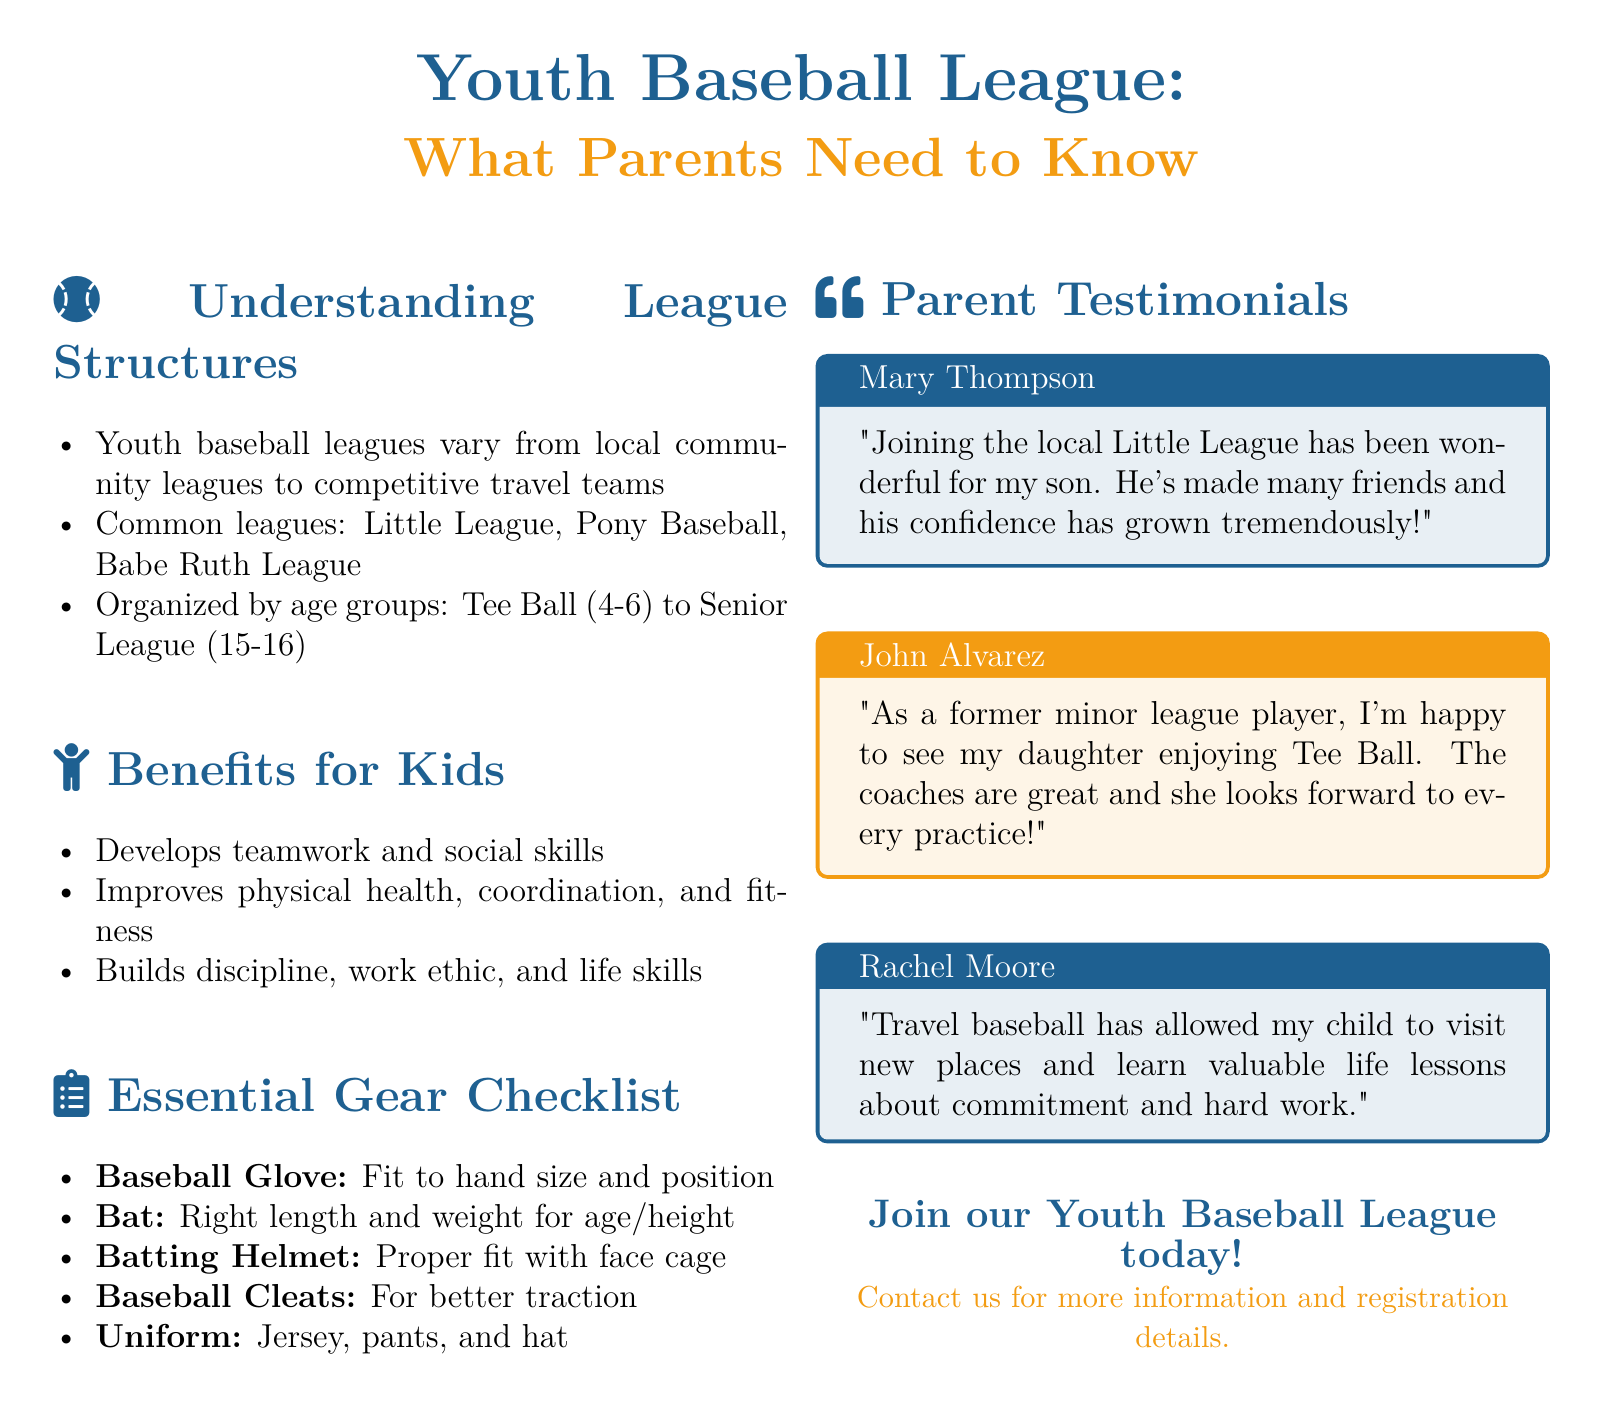What are the common leagues mentioned? The document lists common youth baseball leagues, which include Little League, Pony Baseball, and Babe Ruth League.
Answer: Little League, Pony Baseball, Babe Ruth League What is the age range for Tee Ball? Tee Ball is specifically organized for a certain age group, which is mentioned in the document.
Answer: 4-6 What essential gear is needed for youth baseball? The document provides a checklist of essential gear, one of which is the baseball glove.
Answer: Baseball Glove How does youth baseball benefit kids? The document highlights several benefits of youth baseball for children, including developing teamwork and social skills.
Answer: Teamwork and social skills Who provided a testimonial about Tee Ball? The document includes parent testimonials, one of which mentions a child enjoying Tee Ball from a former minor league player.
Answer: John Alvarez What does Rachel Moore say about travel baseball? The document provides insights from a parent (Rachel Moore) on the advantages of travel baseball for her child.
Answer: Learning valuable life lessons about commitment and hard work What color is the accent color in the document? The document specifies the color codes used, including the accent color for certain sections.
Answer: F39C12 How many age groups are listed in the document? The document divides youth baseball into age groups ranging from Tee Ball to Senior League; this implies there are multiple categories mentioned.
Answer: Multiple (specific numbers are not provided) 